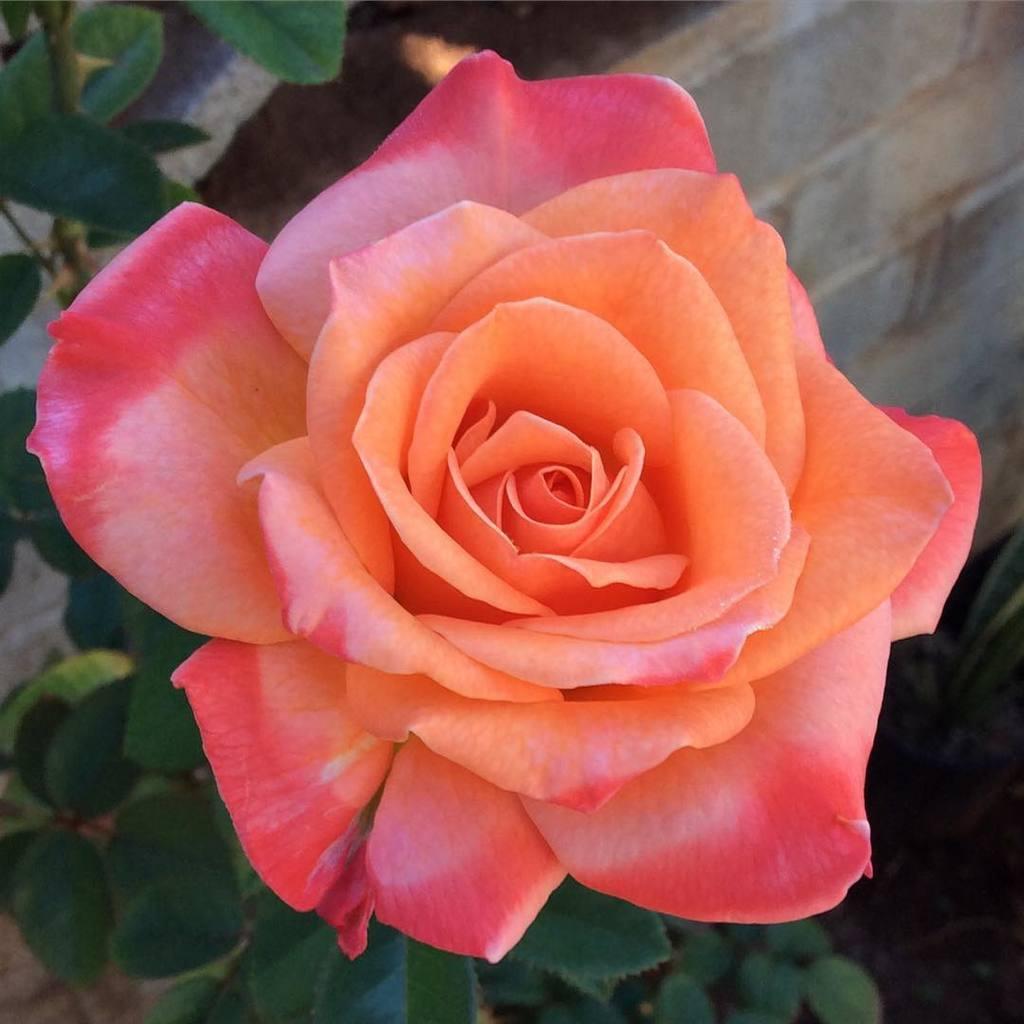Describe this image in one or two sentences. In this picture there is a flower on the plant and the flower is in pink and orange color. At the back there is a wall. At the bottom there is a plant. 